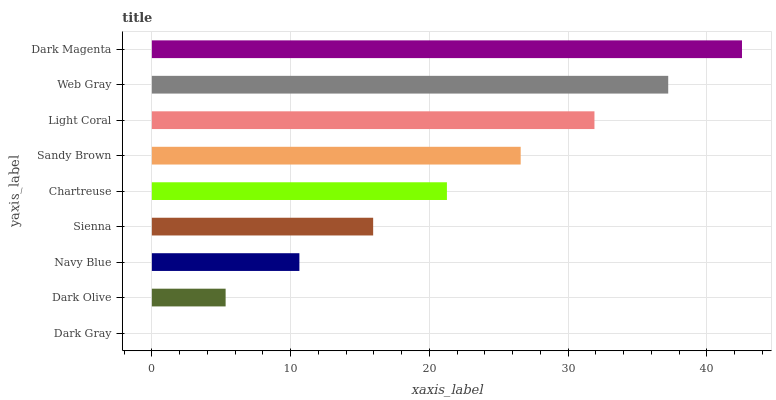Is Dark Gray the minimum?
Answer yes or no. Yes. Is Dark Magenta the maximum?
Answer yes or no. Yes. Is Dark Olive the minimum?
Answer yes or no. No. Is Dark Olive the maximum?
Answer yes or no. No. Is Dark Olive greater than Dark Gray?
Answer yes or no. Yes. Is Dark Gray less than Dark Olive?
Answer yes or no. Yes. Is Dark Gray greater than Dark Olive?
Answer yes or no. No. Is Dark Olive less than Dark Gray?
Answer yes or no. No. Is Chartreuse the high median?
Answer yes or no. Yes. Is Chartreuse the low median?
Answer yes or no. Yes. Is Dark Olive the high median?
Answer yes or no. No. Is Dark Gray the low median?
Answer yes or no. No. 